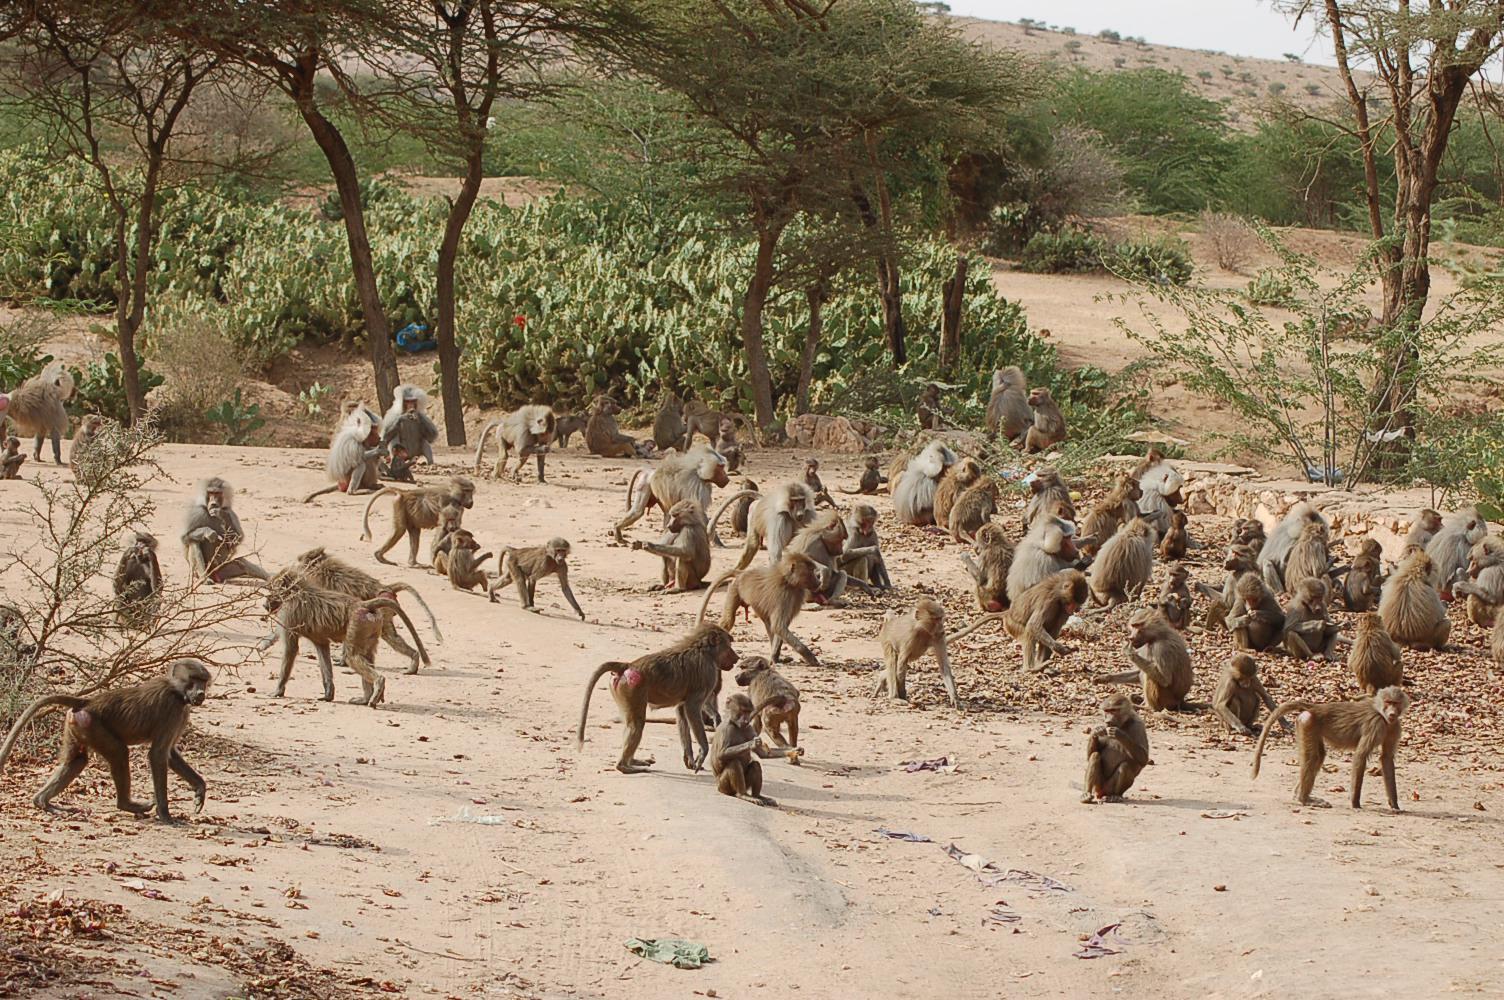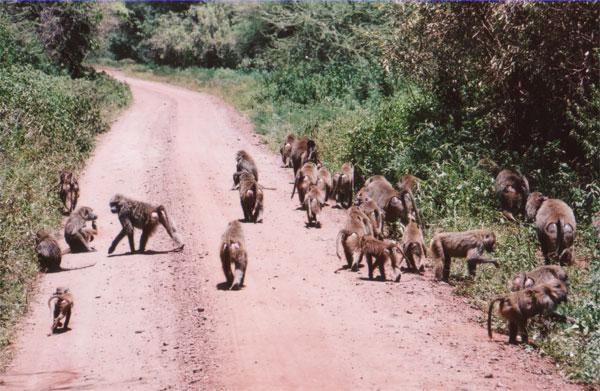The first image is the image on the left, the second image is the image on the right. Considering the images on both sides, is "There are two groups of monkeys in the center of the images." valid? Answer yes or no. No. 